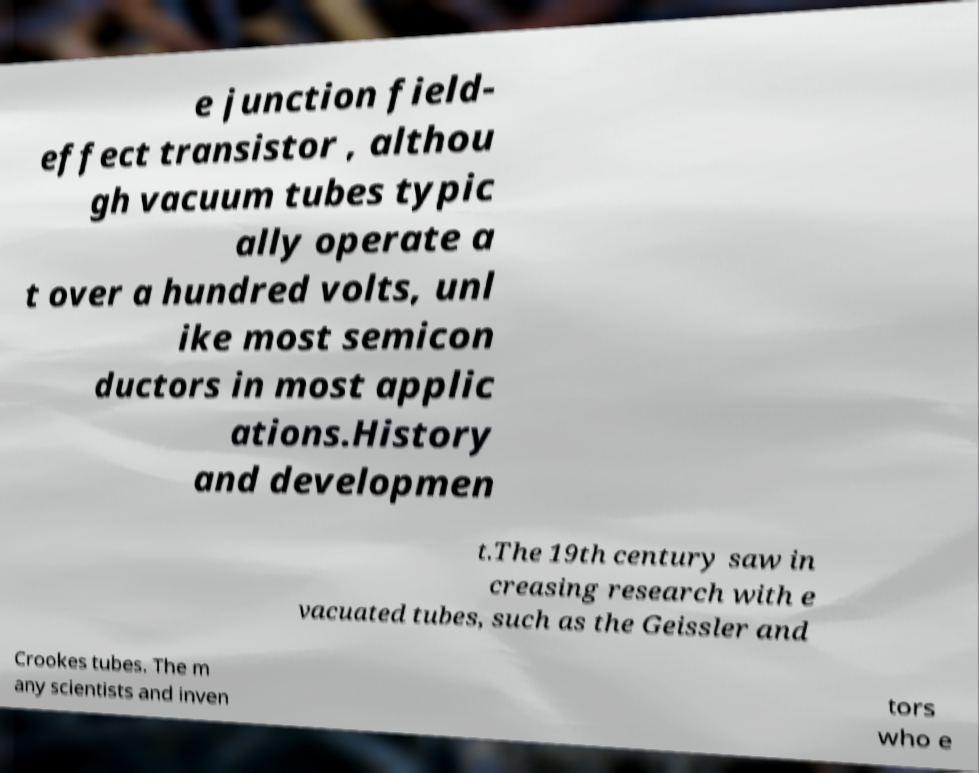What messages or text are displayed in this image? I need them in a readable, typed format. e junction field- effect transistor , althou gh vacuum tubes typic ally operate a t over a hundred volts, unl ike most semicon ductors in most applic ations.History and developmen t.The 19th century saw in creasing research with e vacuated tubes, such as the Geissler and Crookes tubes. The m any scientists and inven tors who e 